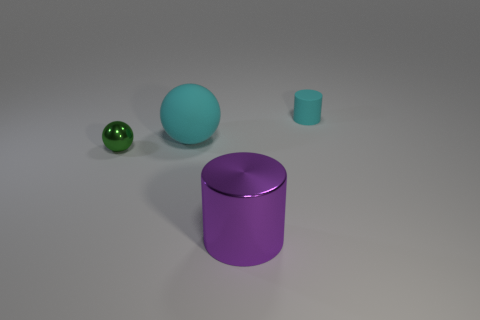Add 2 big purple metallic cylinders. How many objects exist? 6 Add 1 small cyan rubber cylinders. How many small cyan rubber cylinders are left? 2 Add 3 cyan cylinders. How many cyan cylinders exist? 4 Subtract 1 green balls. How many objects are left? 3 Subtract all green metallic spheres. Subtract all big objects. How many objects are left? 1 